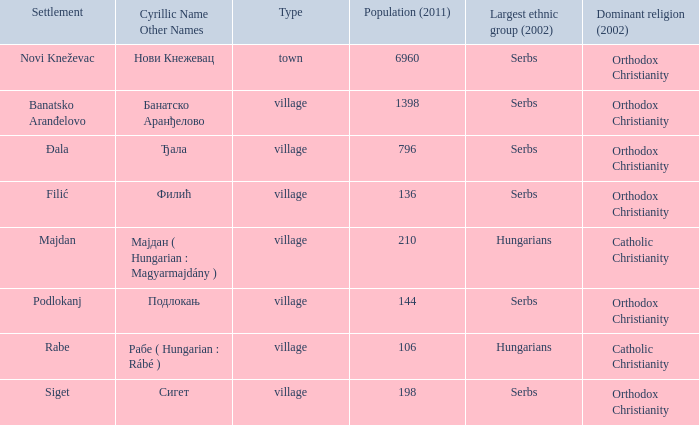What type of settlement is rabe? Village. 